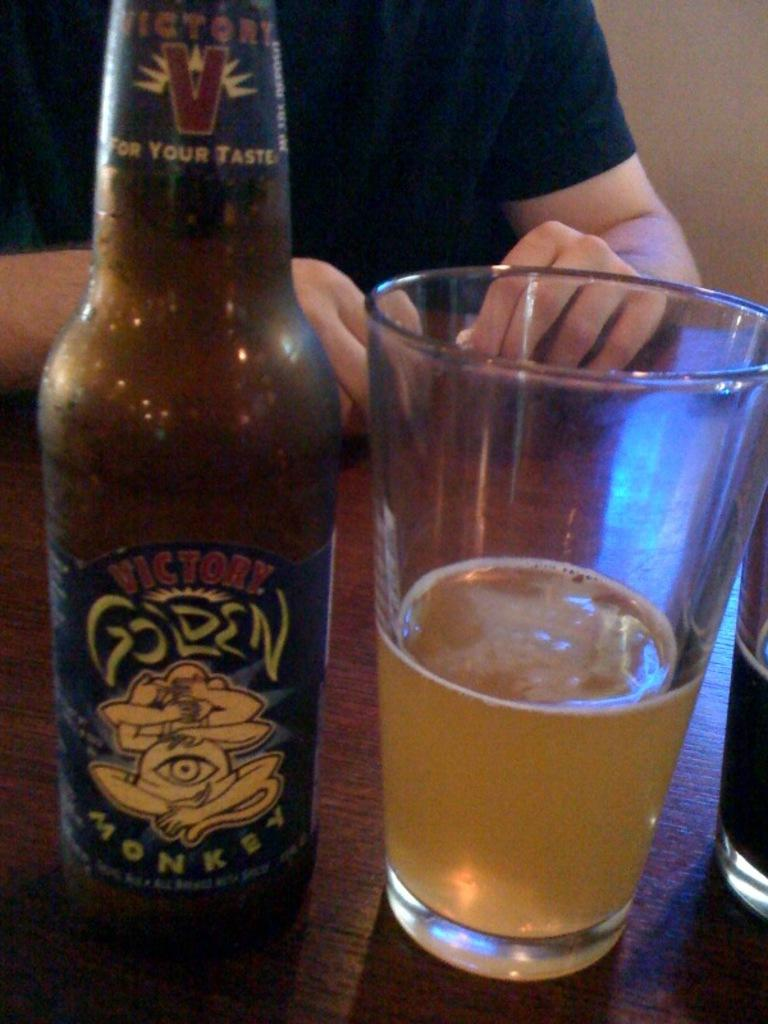<image>
Present a compact description of the photo's key features. a person with a beer bottle that says Golden next to them 